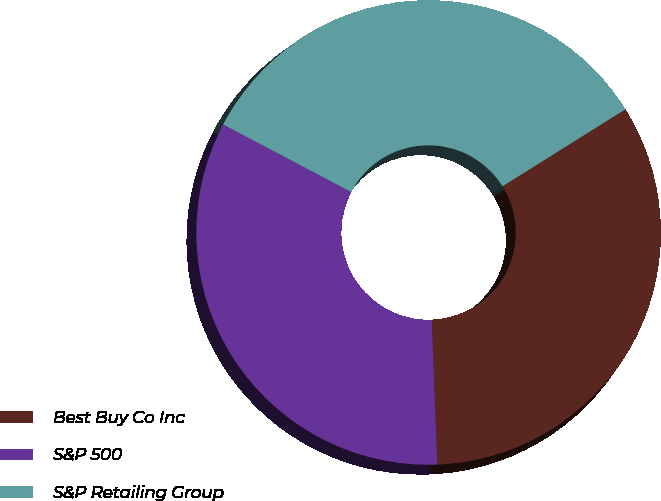<chart> <loc_0><loc_0><loc_500><loc_500><pie_chart><fcel>Best Buy Co Inc<fcel>S&P 500<fcel>S&P Retailing Group<nl><fcel>33.3%<fcel>33.33%<fcel>33.37%<nl></chart> 